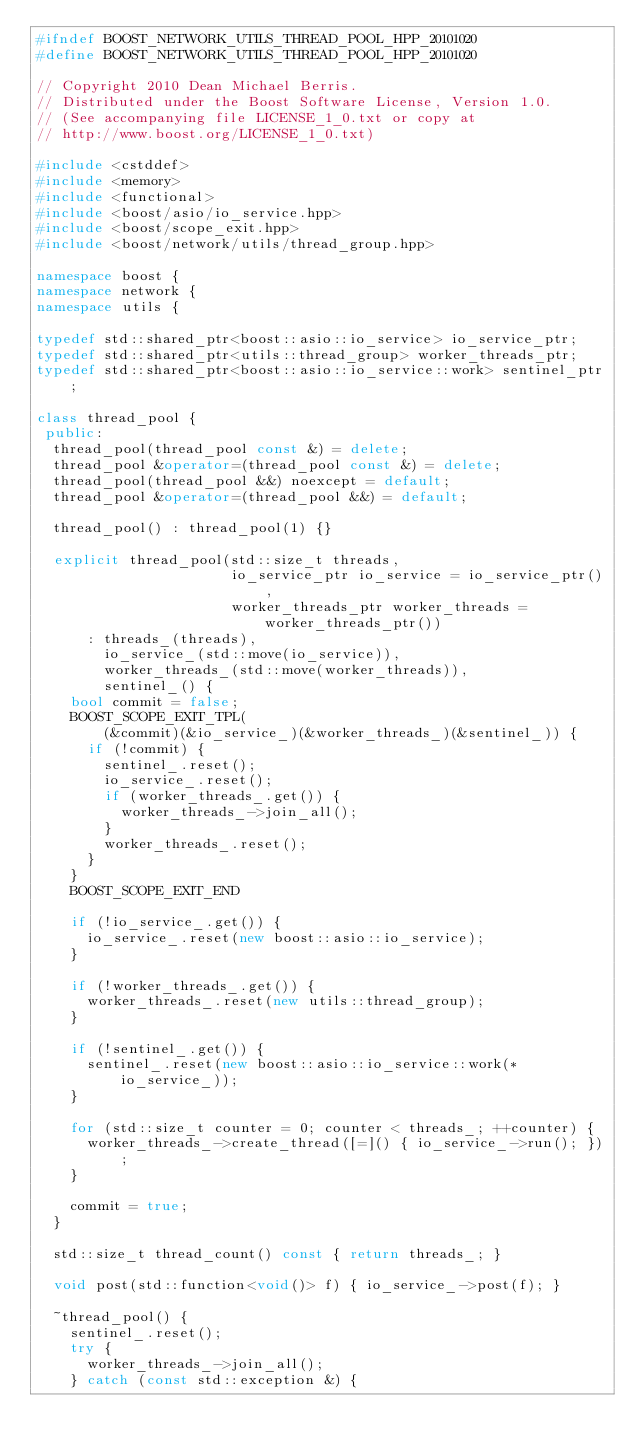<code> <loc_0><loc_0><loc_500><loc_500><_C++_>#ifndef BOOST_NETWORK_UTILS_THREAD_POOL_HPP_20101020
#define BOOST_NETWORK_UTILS_THREAD_POOL_HPP_20101020

// Copyright 2010 Dean Michael Berris.
// Distributed under the Boost Software License, Version 1.0.
// (See accompanying file LICENSE_1_0.txt or copy at
// http://www.boost.org/LICENSE_1_0.txt)

#include <cstddef>
#include <memory>
#include <functional>
#include <boost/asio/io_service.hpp>
#include <boost/scope_exit.hpp>
#include <boost/network/utils/thread_group.hpp>

namespace boost {
namespace network {
namespace utils {

typedef std::shared_ptr<boost::asio::io_service> io_service_ptr;
typedef std::shared_ptr<utils::thread_group> worker_threads_ptr;
typedef std::shared_ptr<boost::asio::io_service::work> sentinel_ptr;

class thread_pool {
 public:
  thread_pool(thread_pool const &) = delete;
  thread_pool &operator=(thread_pool const &) = delete;
  thread_pool(thread_pool &&) noexcept = default;
  thread_pool &operator=(thread_pool &&) = default;

  thread_pool() : thread_pool(1) {}

  explicit thread_pool(std::size_t threads,
                       io_service_ptr io_service = io_service_ptr(),
                       worker_threads_ptr worker_threads = worker_threads_ptr())
      : threads_(threads),
        io_service_(std::move(io_service)),
        worker_threads_(std::move(worker_threads)),
        sentinel_() {
    bool commit = false;
    BOOST_SCOPE_EXIT_TPL(
        (&commit)(&io_service_)(&worker_threads_)(&sentinel_)) {
      if (!commit) {
        sentinel_.reset();
        io_service_.reset();
        if (worker_threads_.get()) {
          worker_threads_->join_all();
        }
        worker_threads_.reset();
      }
    }
    BOOST_SCOPE_EXIT_END

    if (!io_service_.get()) {
      io_service_.reset(new boost::asio::io_service);
    }

    if (!worker_threads_.get()) {
      worker_threads_.reset(new utils::thread_group);
    }

    if (!sentinel_.get()) {
      sentinel_.reset(new boost::asio::io_service::work(*io_service_));
    }

    for (std::size_t counter = 0; counter < threads_; ++counter) {
      worker_threads_->create_thread([=]() { io_service_->run(); });
    }

    commit = true;
  }

  std::size_t thread_count() const { return threads_; }

  void post(std::function<void()> f) { io_service_->post(f); }

  ~thread_pool() {
    sentinel_.reset();
    try {
      worker_threads_->join_all();
    } catch (const std::exception &) {</code> 